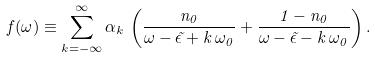<formula> <loc_0><loc_0><loc_500><loc_500>f ( \omega ) \equiv \sum ^ { \infty } _ { k = - \infty } \alpha _ { k } \, \left ( \frac { n _ { 0 } } { \omega - \tilde { \epsilon } + k \, \omega _ { 0 } } + \frac { 1 - n _ { 0 } } { \omega - \tilde { \epsilon } - k \, \omega _ { 0 } } \right ) .</formula> 